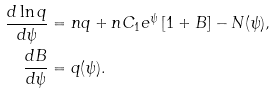Convert formula to latex. <formula><loc_0><loc_0><loc_500><loc_500>\frac { d \ln q } { d \psi } & = n q + n C _ { 1 } e ^ { \psi } \left [ 1 + B \right ] - N ( \psi ) , \\ \frac { d B } { d \psi } & = q ( \psi ) .</formula> 